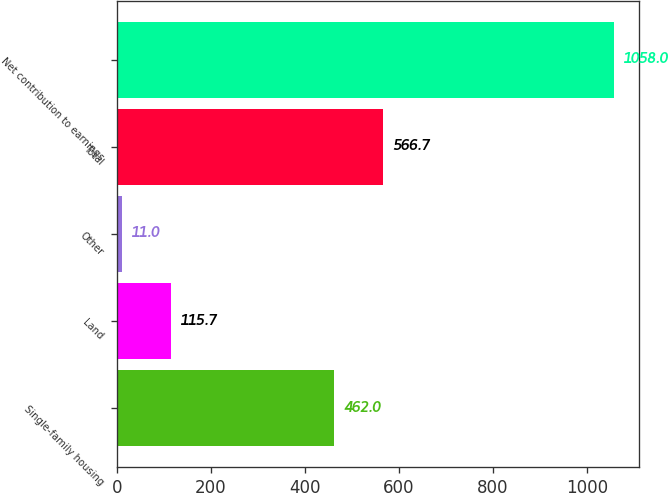Convert chart. <chart><loc_0><loc_0><loc_500><loc_500><bar_chart><fcel>Single-family housing<fcel>Land<fcel>Other<fcel>Total<fcel>Net contribution to earnings<nl><fcel>462<fcel>115.7<fcel>11<fcel>566.7<fcel>1058<nl></chart> 